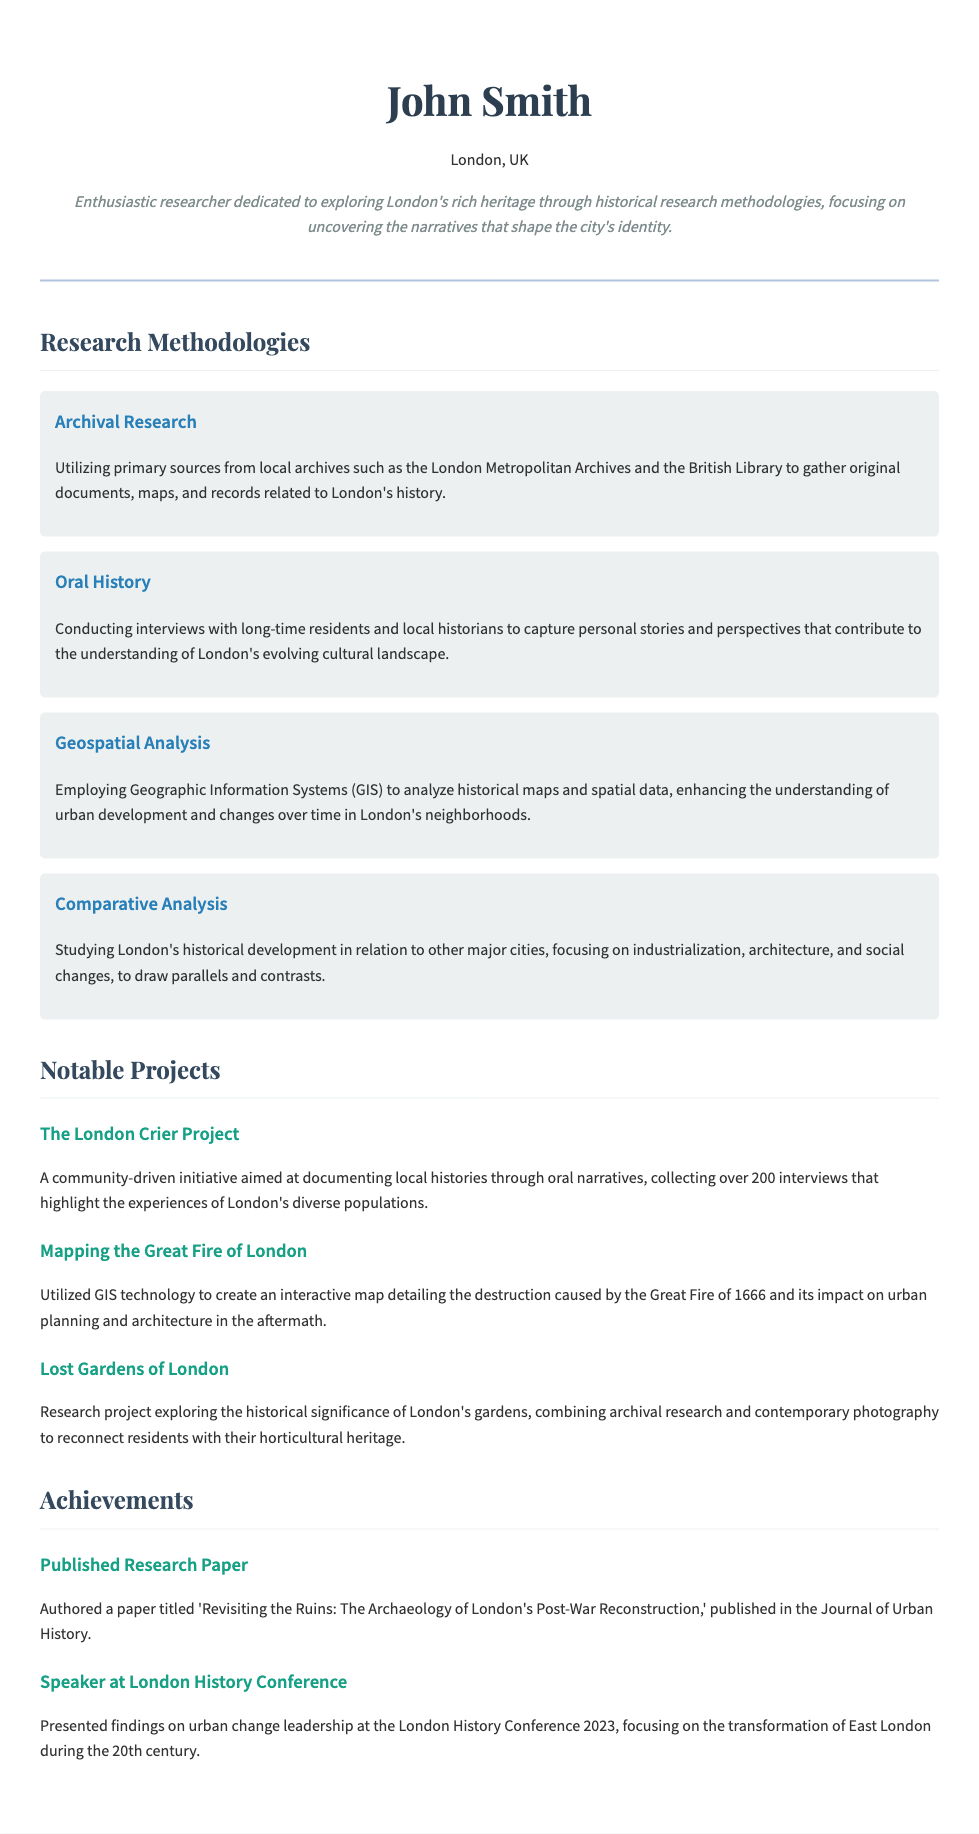What is the research paper title authored by John Smith? The title of the research paper is mentioned in the achievements section of the CV.
Answer: Revisiting the Ruins: The Archaeology of London's Post-War Reconstruction Which major project involved oral narratives? This information can be found in the notable projects section, specifically the projects focused on community and individual stories.
Answer: The London Crier Project What type of analysis does John Smith use for studying historical maps? This is detailed under the research methodologies, specifying the analytical technique utilized.
Answer: Geospatial Analysis In which year was the London History Conference held? The conference year is referenced in the achievements section, indicating when the findings were presented.
Answer: 2023 What is the main focus of the "Lost Gardens of London" project? This question refers to the objective outlined in the notable projects section.
Answer: Historical significance of London's gardens How many interviews were collected during The London Crier Project? The document specifies the number of interviews collected in the notable projects section.
Answer: Over 200 interviews What archival institution does John Smith use for research? This information is available in the research methodologies section that describes the sources used for archival research.
Answer: London Metropolitan Archives What methodology captures personal stories from residents? This refers to a specific research method described in the research methodologies section focused on individual narratives.
Answer: Oral History 